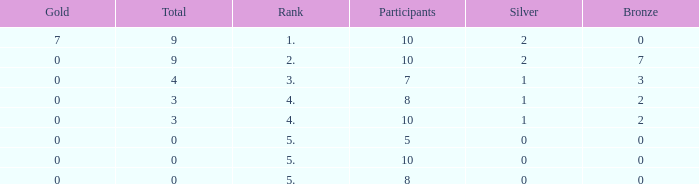What is listed as the highest Participants that also have a Rank of 5, and Silver that's smaller than 0? None. 